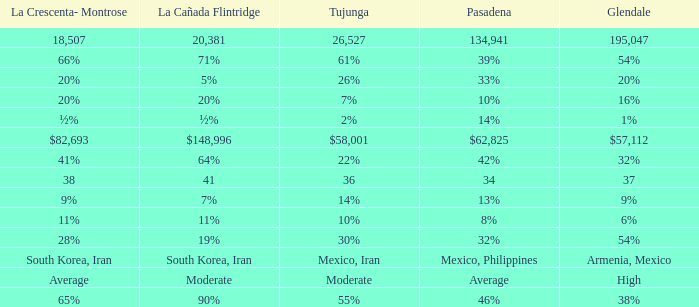Give me the full table as a dictionary. {'header': ['La Crescenta- Montrose', 'La Cañada Flintridge', 'Tujunga', 'Pasadena', 'Glendale'], 'rows': [['18,507', '20,381', '26,527', '134,941', '195,047'], ['66%', '71%', '61%', '39%', '54%'], ['20%', '5%', '26%', '33%', '20%'], ['20%', '20%', '7%', '10%', '16%'], ['½%', '½%', '2%', '14%', '1%'], ['$82,693', '$148,996', '$58,001', '$62,825', '$57,112'], ['41%', '64%', '22%', '42%', '32%'], ['38', '41', '36', '34', '37'], ['9%', '7%', '14%', '13%', '9%'], ['11%', '11%', '10%', '8%', '6%'], ['28%', '19%', '30%', '32%', '54%'], ['South Korea, Iran', 'South Korea, Iran', 'Mexico, Iran', 'Mexico, Philippines', 'Armenia, Mexico'], ['Average', 'Moderate', 'Moderate', 'Average', 'High'], ['65%', '90%', '55%', '46%', '38%']]} What is the figure for Tujunga when Pasadena is 134,941? 26527.0. 